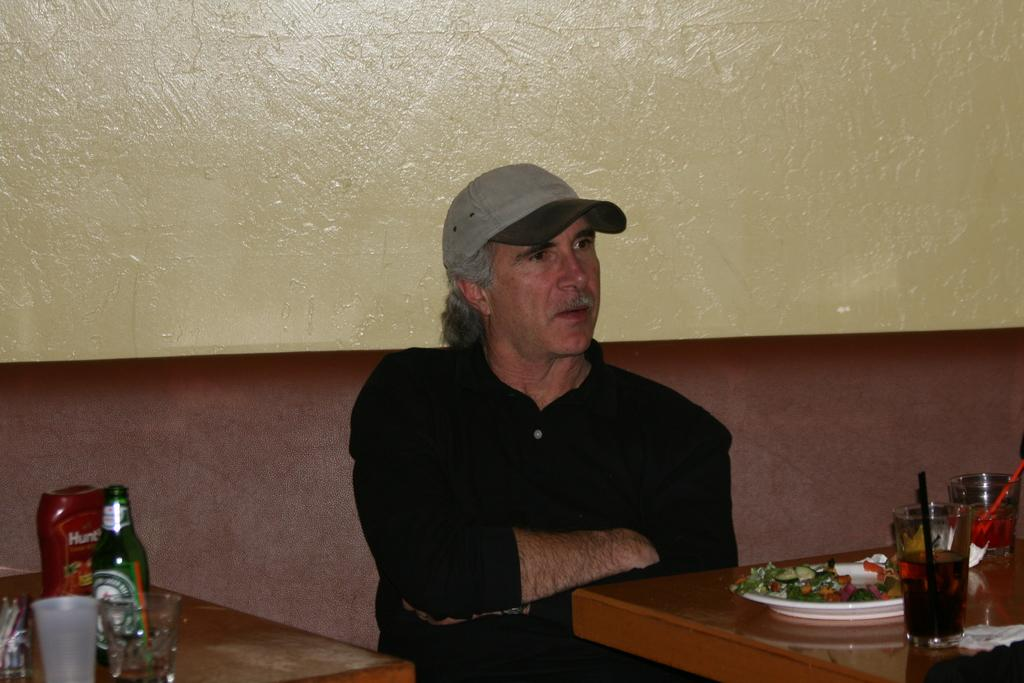<image>
Relay a brief, clear account of the picture shown. A man is sitting with arms crossed at a restaurant table with Hunt's ketchup on it. 